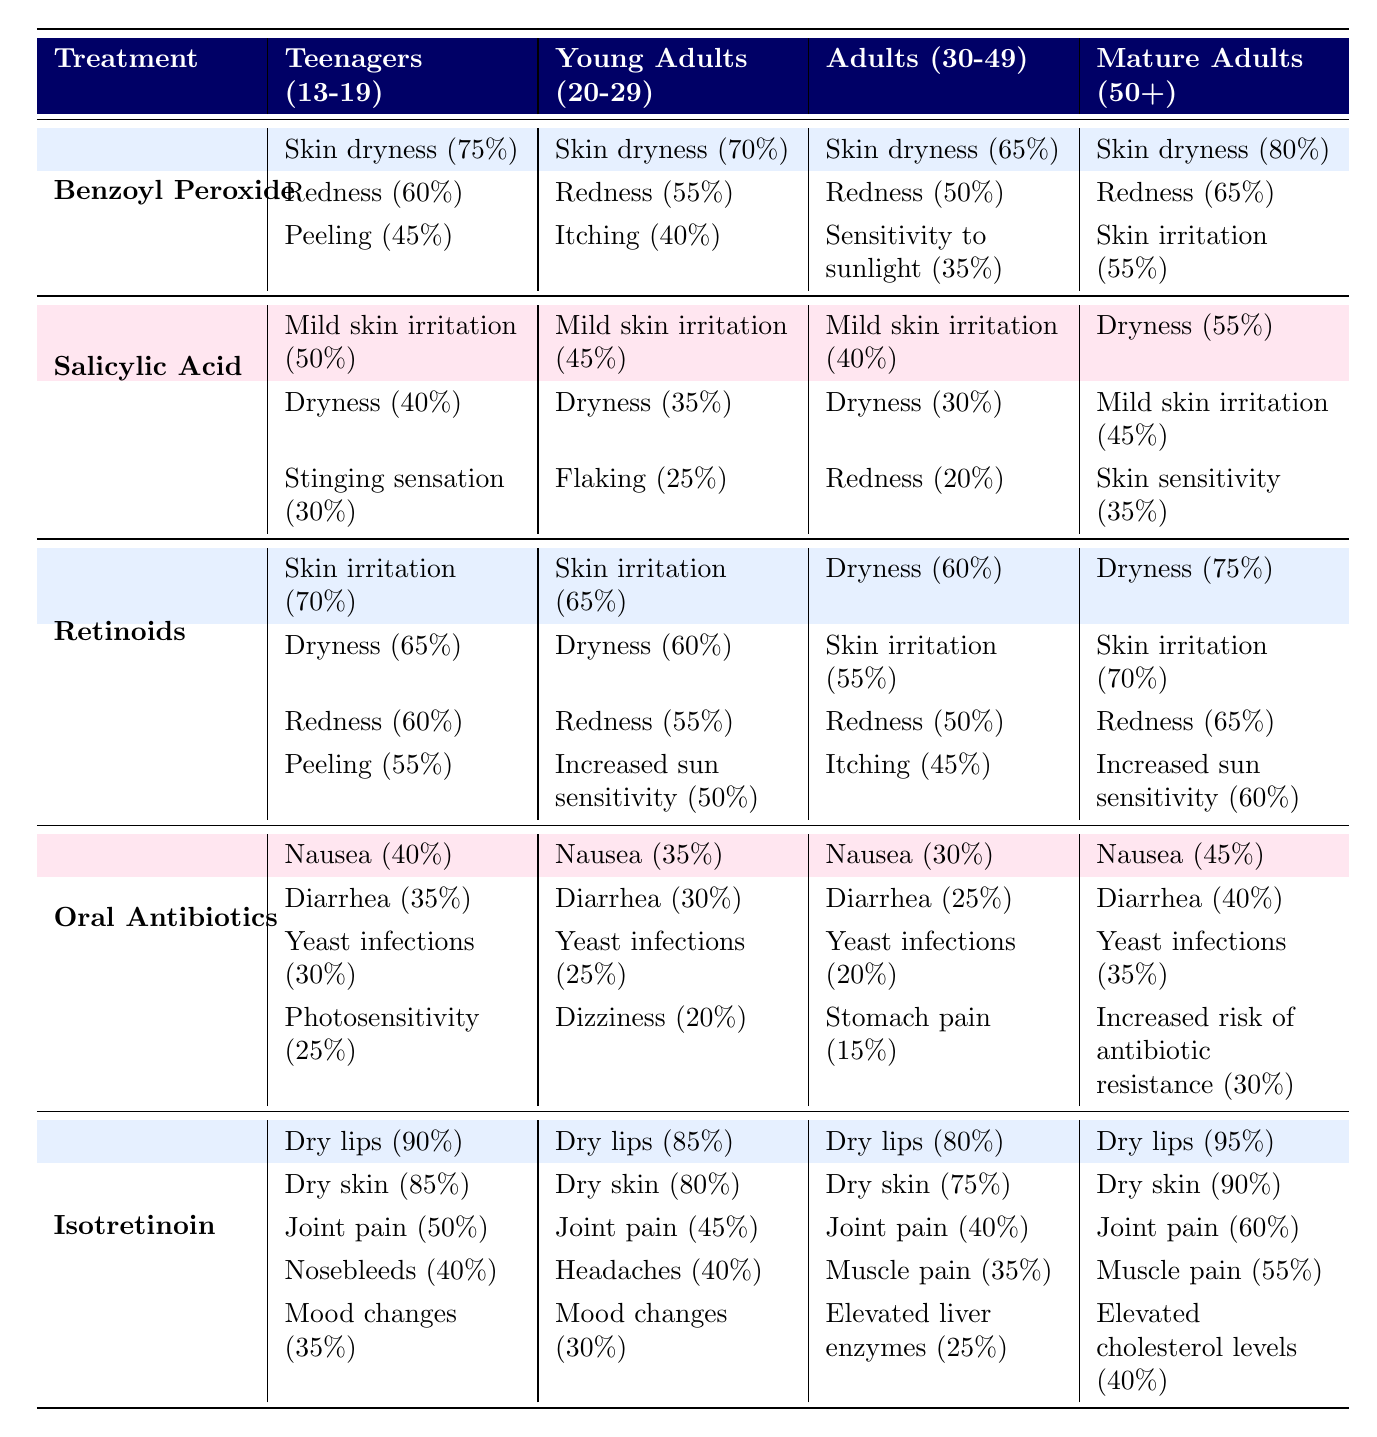What percentage of teenagers experience skin dryness with Isotretinoin? The table indicates that 90% of teenagers experience dry lips and 85% report dry skin when using Isotretinoin. Therefore, when referring to just skin dryness, it is 85% in total, focusing on dry skin specifically.
Answer: 85% Which treatment has the highest reported side effect of "Nausea" in mature adults? The table shows that for mature adults, Isotretinoin has a nausea report of 45%, while Oral Antibiotics has a report of 45% as well. Thus, both share the highest percentage for this side effect.
Answer: Yes, both Isotretinoin and Oral Antibiotics have the same highest percentage of 45% What is the difference in percentage of skin irritation side effects between teenagers and young adults for Retinoids? For teenagers, the percentage of skin irritation for Retinoids is 70%, and for young adults, it is 65%. The difference is calculated as 70% - 65% = 5%.
Answer: 5% Does Benzoyl Peroxide cause more skin dryness in teenagers than in adults aged 30-49? According to the table, Benzoyl Peroxide causes 75% skin dryness in teenagers and 65% in adults aged 30-49. Therefore, it indeed causes more skin dryness in teenagers.
Answer: Yes Which treatment causes the least "Dryness" side effect for young adults and what is the percentage? Referring to the table, for young adults, the least dryness percentage is attributed to Salicylic Acid at 35%.
Answer: Salicylic Acid (35%) If a mature adult takes Oral Antibiotics, what is the combined percentage of "Diarrhea" and "Yeast infections" side effects? For mature adults, Diarrhea has a percentage of 40% and Yeast infections have a percentage of 35%. Combining these gives 40% + 35% = 75%.
Answer: 75% How many treatments reported "Redness" as a side effect across all age groups? The treatments that reported redness are Benzoyl Peroxide, Salicylic Acid, and Retinoids. Thus, there are three treatments in total that mention this side effect.
Answer: 3 What percentage of mature adults using Retinoids reported increased sun sensitivity? The table indicates that 60% of mature adults using Retinoids reported increased sun sensitivity.
Answer: 60% Is there a higher percentage of "Joint pain" reported by young adults or mature adults when using Isotretinoin? For Isotretinoin, young adults report joint pain at 45%, whereas mature adults report it at 60%. Thus, mature adults report a higher percentage.
Answer: Mature adults (60%) 